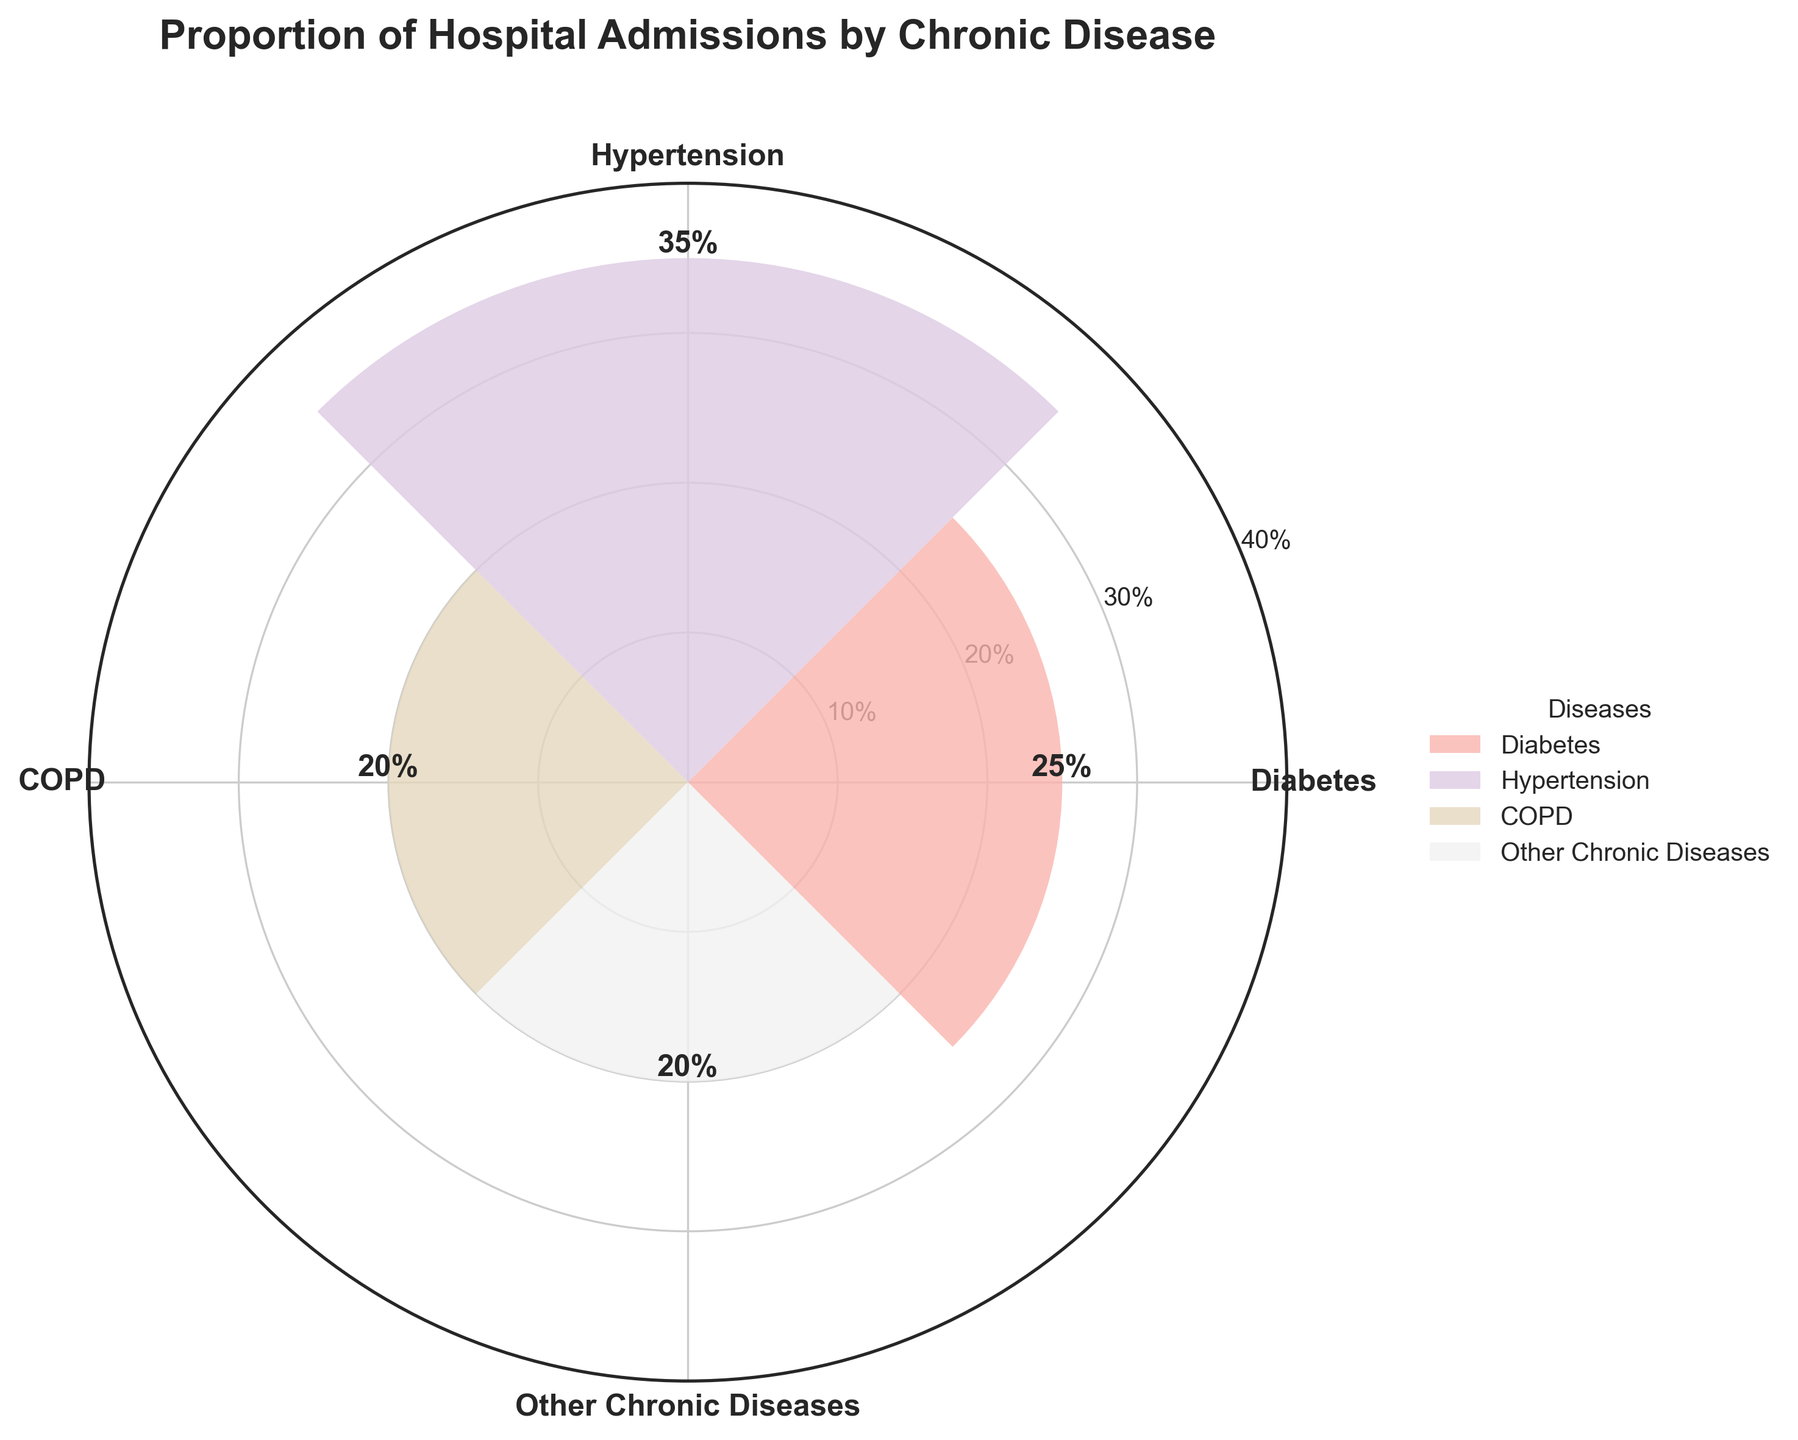What is the title of the figure? The title of the figure is displayed at the top and provides context about what the figure represents.
Answer: Proportion of Hospital Admissions by Chronic Disease What does the widest segment in the chart represent? The widest segment indicates the highest proportion of hospital admissions, which can be identified by the size of the segment and the associated label.
Answer: Hypertension How many chronic diseases are represented in the figure? The diagram has segments for each chronic disease, which can be counted based on the unique labels around the chart.
Answer: 4 What proportion of hospital admissions is due to COPD? The height of the segment labeled COPD represents its share, which is numerically displayed at the top of that segment.
Answer: 20% Which chronic disease has the smallest proportion of hospital admissions? The smallest segment in the chart, based on both visual size and the percentage label, indicates the disease with the least proportion.
Answer: COPD and Other Chronic Diseases (each 20%) What is the combined proportion of hospital admissions for Diabetes and Hypertension? Sum the proportions of the segments labeled Diabetes and Hypertension. The individual proportions are identified by their labels on the chart.
Answer: 25% + 35% = 60% Which two chronic diseases have equal proportions of hospital admissions? Identify the segments with the same height and percentage labels. In this case, compare the percentages displayed for each segment.
Answer: COPD and Other Chronic Diseases Is the proportion of hospital admissions due to Diabetes greater than that of COPD? Compare the proportions given for Diabetes and COPD from their segments' labels.
Answer: Yes What is the difference in the proportion of admissions between Diabetes and Hypertension? Subtract the proportion of Diabetes from that of Hypertension, both of which are labeled on their respective segments.
Answer: 35% - 25% = 10% Are any chronic diseases represented with a share of hospital admissions exactly one-third? Check the labeled proportions on the segments to see if any equal 33.3%.
Answer: No 